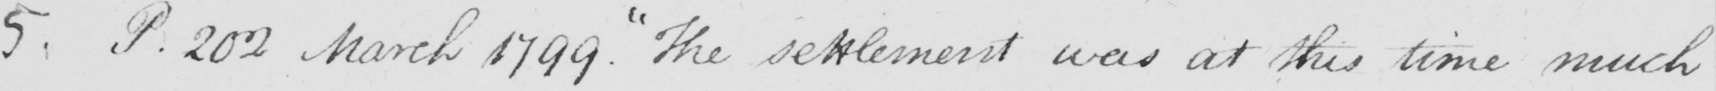What does this handwritten line say? 5 . P.202 March 1799 .  " The settlement was at this time much 